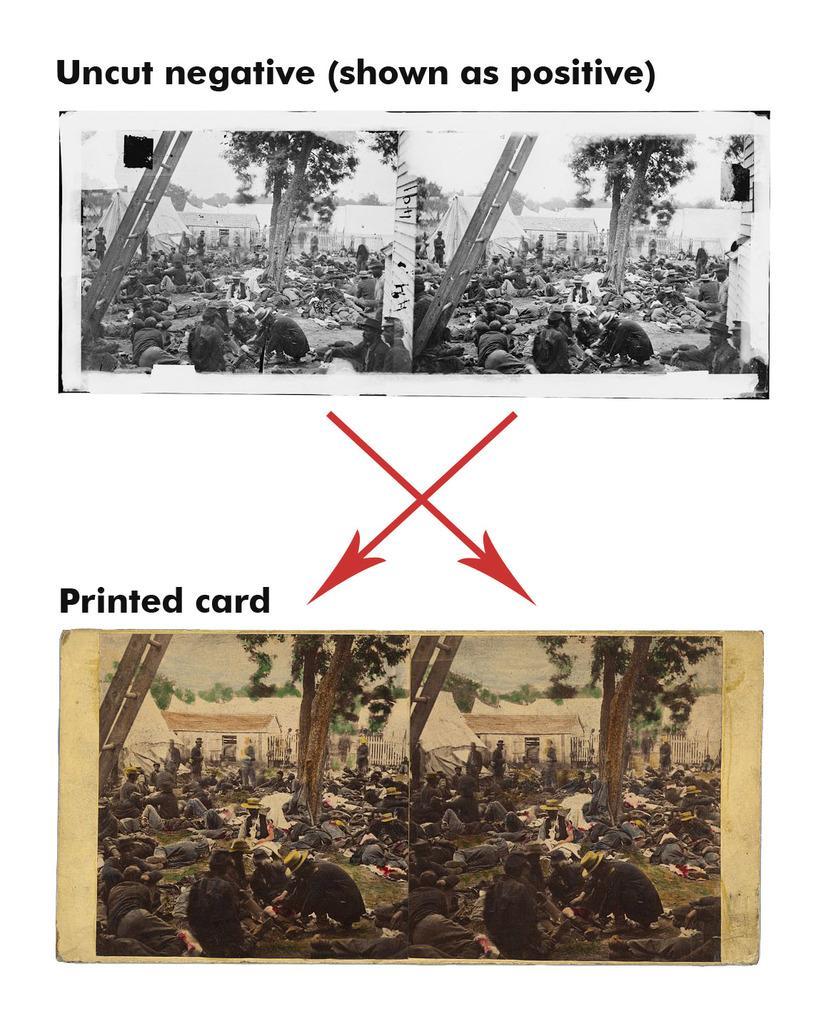Can you describe this image briefly? This looks like an editor and collage picture. I can see groups of people sitting and few people standing. I can see the ladders. These are the trees and the houses. I can see the letters and the arrow marks on the image. 